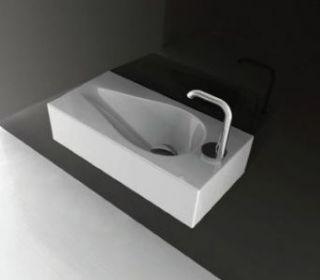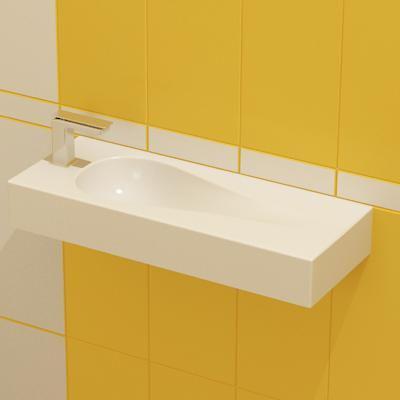The first image is the image on the left, the second image is the image on the right. For the images shown, is this caption "The right image features two tear-drop carved white sinks positioned side-by-side." true? Answer yes or no. No. The first image is the image on the left, the second image is the image on the right. Considering the images on both sides, is "In one image, two rectangular sinks with chrome faucet fixture are positioned side by side." valid? Answer yes or no. No. 